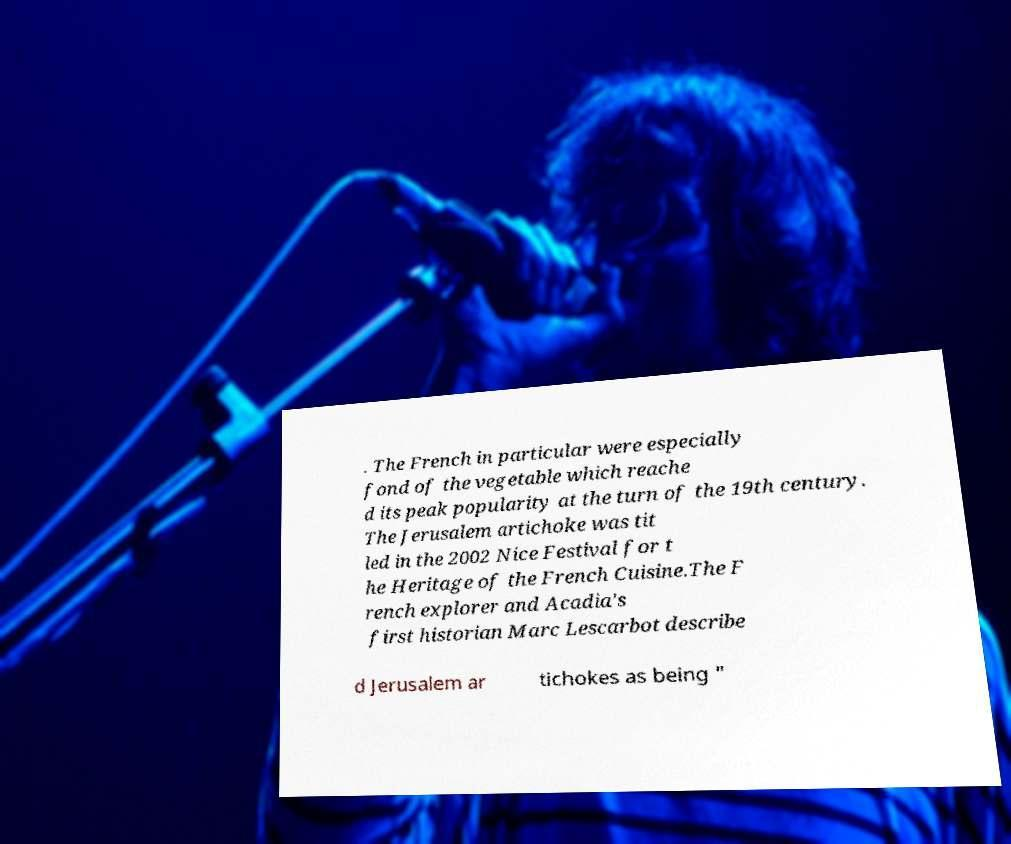What messages or text are displayed in this image? I need them in a readable, typed format. . The French in particular were especially fond of the vegetable which reache d its peak popularity at the turn of the 19th century. The Jerusalem artichoke was tit led in the 2002 Nice Festival for t he Heritage of the French Cuisine.The F rench explorer and Acadia's first historian Marc Lescarbot describe d Jerusalem ar tichokes as being " 